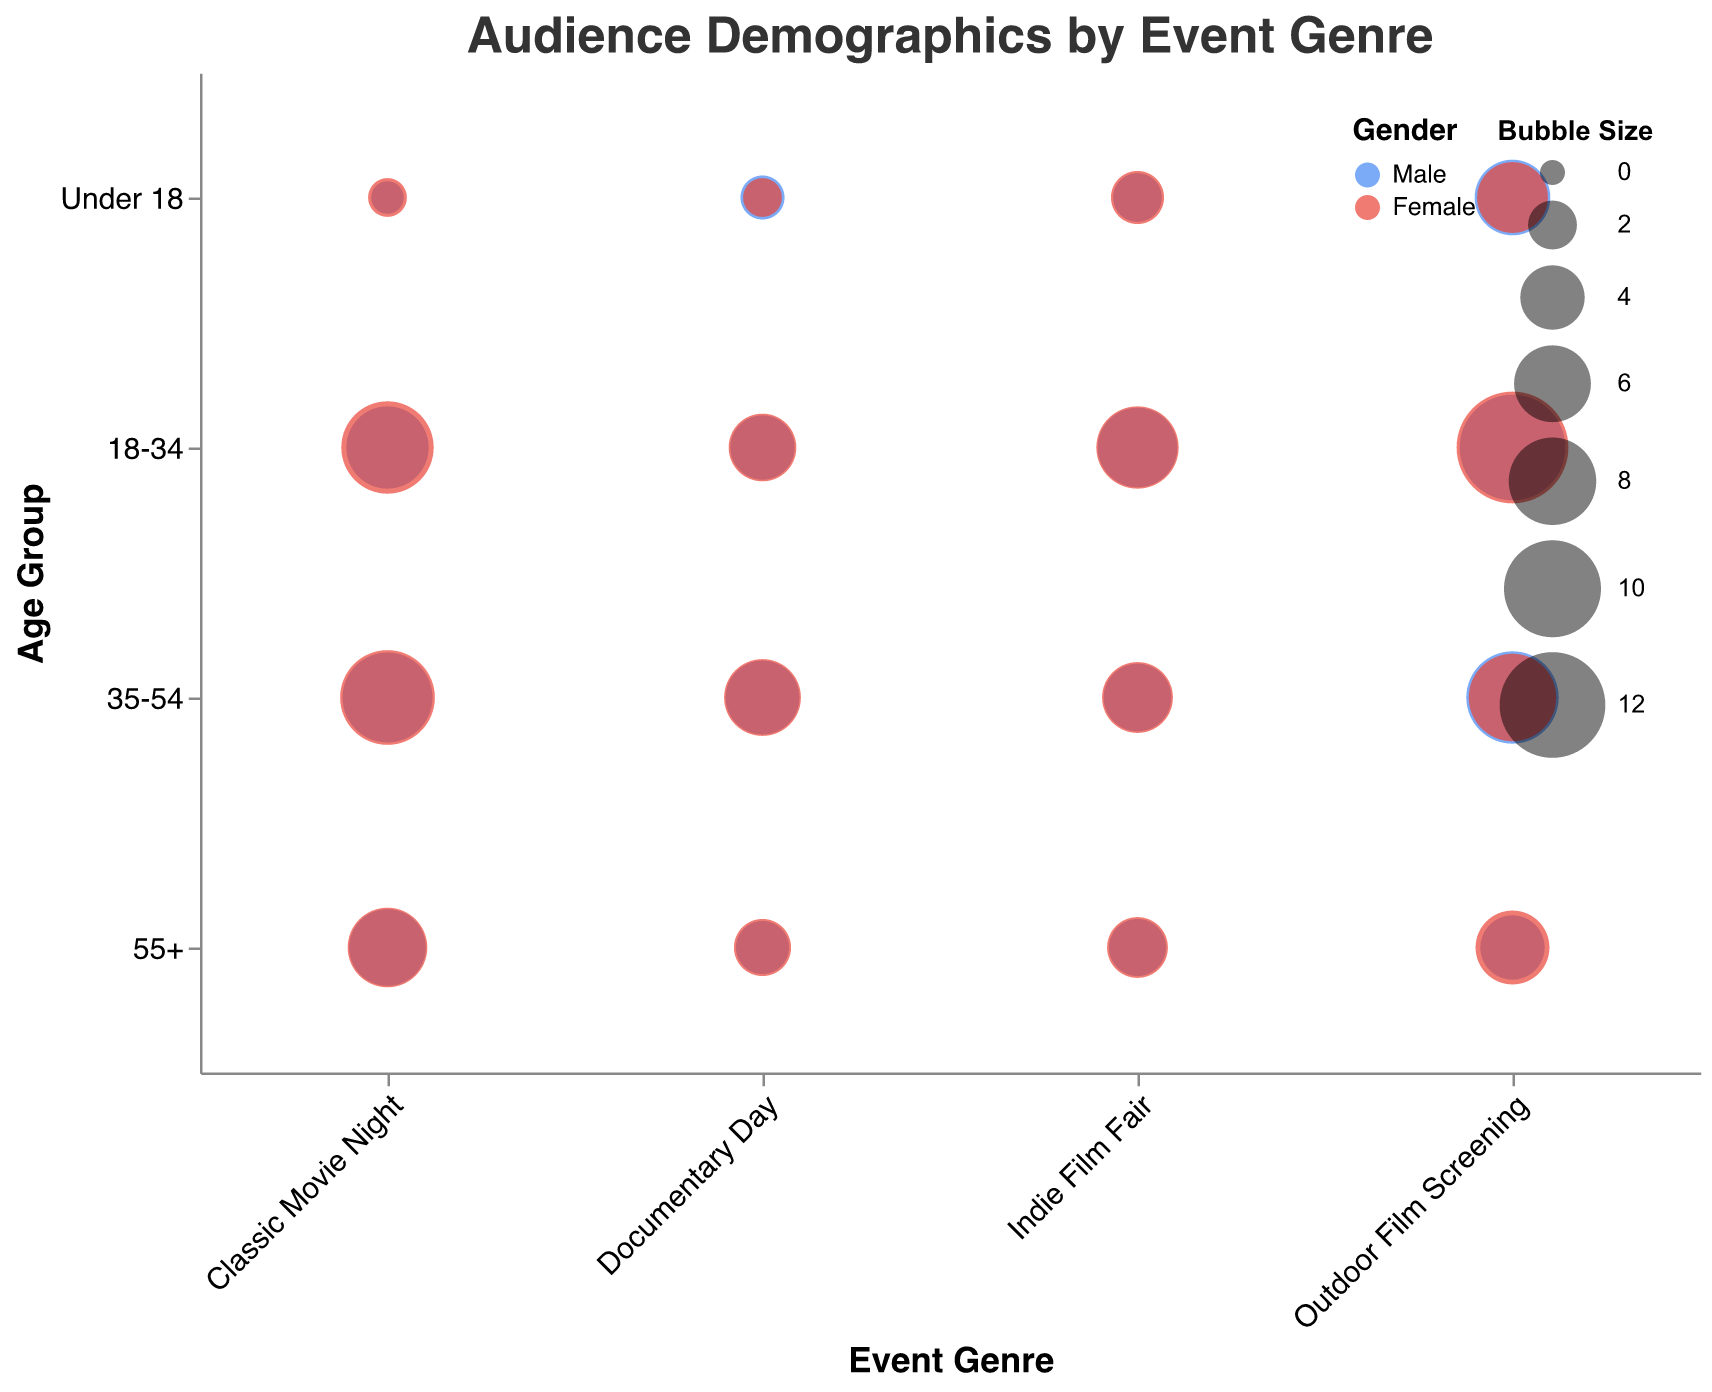What is the title of the chart? The title appears at the top of the chart, which reads "Audience Demographics by Event Genre."
Answer: Audience Demographics by Event Genre Which gender has the larger audience bubble size for the "18-34" age group in the "Outdoor Film Screening" event genre? Look at the "Outdoor Film Screening" event genre and find the bubbles for the "18-34" age group. Compare the bubble sizes for "Male" and "Female." The size for "Female" (13.5) is larger than that for "Male" (12.0).
Answer: Female What is the smallest bubble size observed in the "Classic Movie Night" event genre? Inspect the bubbles for "Classic Movie Night" genre across all age groups. The "Male" audience in the "Under 18" age group has the smallest bubble size of 0.5.
Answer: 0.5 Which event genre has the highest audience count for the "55+" age group? Compare the audience counts for the "55+" age group across all event genres. "Classic Movie Night" has the highest with an audience count of 65 for females.
Answer: Classic Movie Night How many unique event genres are represented in the chart? Each unique event genre appears on the x-axis. Count the distinct event genres listed there: "Outdoor Film Screening," "Indie Film Fair," "Documentary Day," and "Classic Movie Night."
Answer: 4 In the "Indie Film Fair" event genre, which age group shows a higher audience count for females compared to males? For "Indie Film Fair," compare the audience counts of males and females in each age group. The age groups "Under 18," "18-34," "35-54," and "55+" all show higher counts for females compared to males.
Answer: Under 18, 18-34, 35-54, 55+ What is the average bubble size for the "18-34" age group across all event genres? Sum the bubble sizes for the "18-34" age group across "Outdoor Film Screening," "Indie Film Fair," "Documentary Day," and "Classic Movie Night" for both genders and divide by the number of bubbles (4 events x 2 genders = 8). (12 + 13.5 + 6.5 + 7 + 4 + 4.5 + 7 + 9) / 8 = 63.5 / 8.
Answer: 7.94 Which age group in the "Documentary Day" event genre has the highest bubble size? Look at the "Documentary Day" event genre and identify the bubble sizes for each age group. The highest bubble size for "Documentary Day" is 6.0 for females in the "35-54" age group.
Answer: 35-54 Compare the total audience count for "Male" and "Female" in the "18-34" age group across all event genres. Which gender has a higher total count? Add the audience counts for "18-34" males (120 + 65 + 40 + 70 = 295) and "18-34" females (135 + 70 + 45 + 90 = 340) across all genres and compare.
Answer: Female What's the difference in audience count for the "55+" age group between "Outdoor Film Screening" and "Indie Film Fair" for males? Subtract the "Male" audience count of "55+" in "Indie Film Fair" (30) from "Outdoor Film Screening" (40). 40 - 30 = 10
Answer: 10 